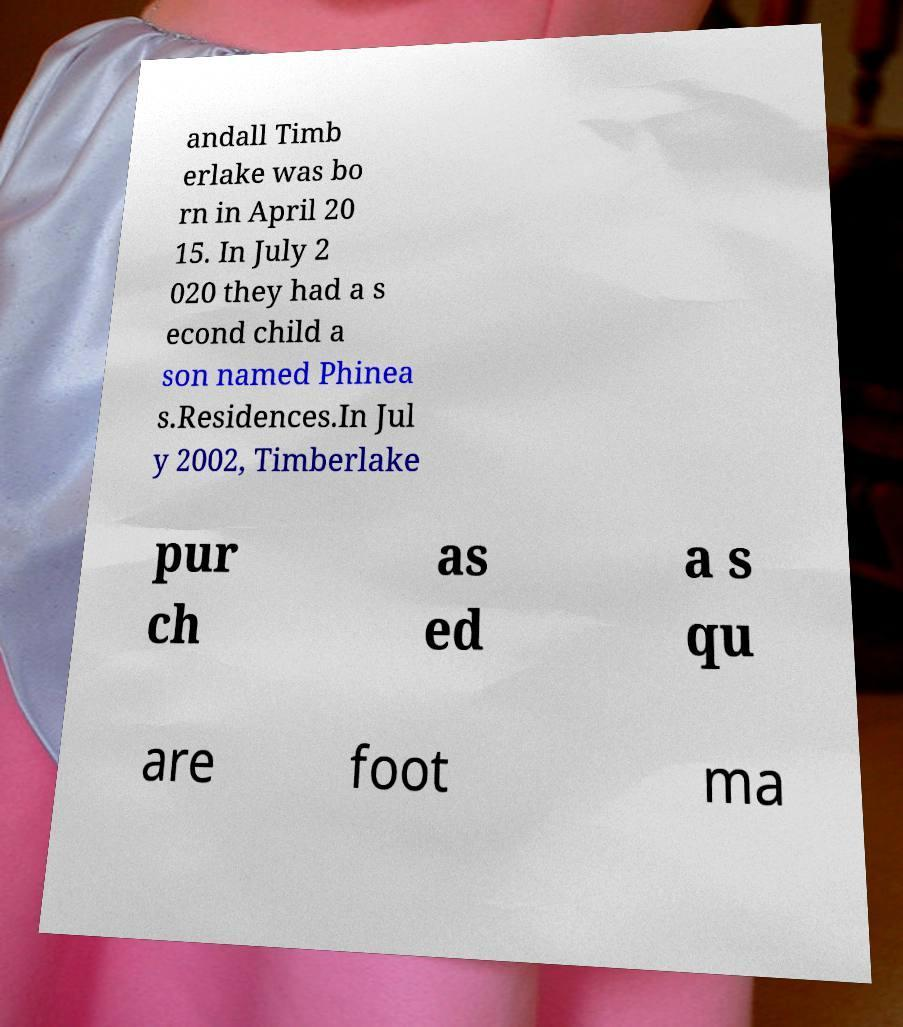Can you read and provide the text displayed in the image?This photo seems to have some interesting text. Can you extract and type it out for me? andall Timb erlake was bo rn in April 20 15. In July 2 020 they had a s econd child a son named Phinea s.Residences.In Jul y 2002, Timberlake pur ch as ed a s qu are foot ma 